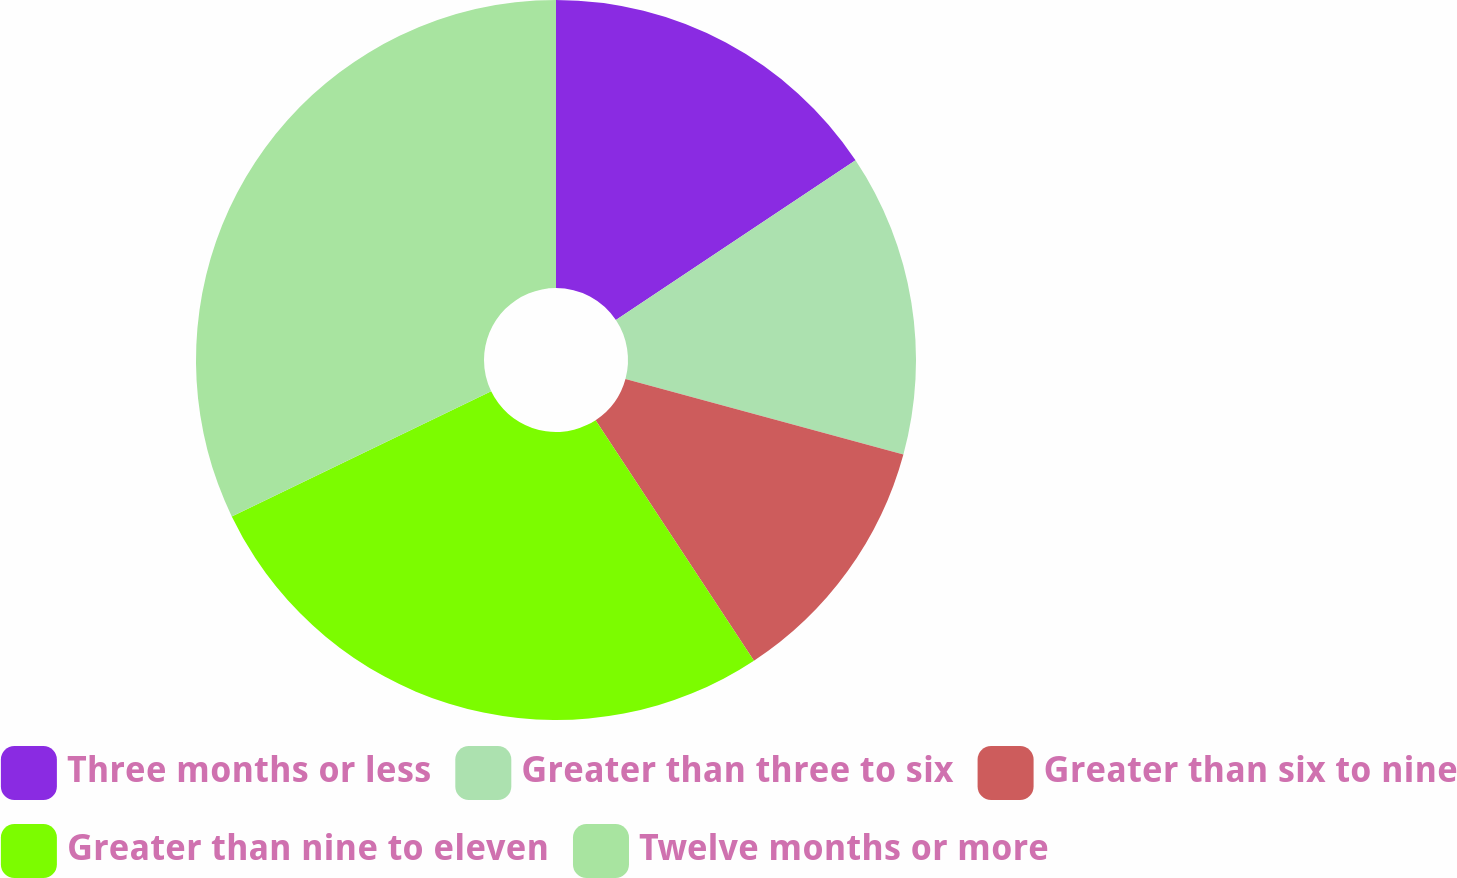<chart> <loc_0><loc_0><loc_500><loc_500><pie_chart><fcel>Three months or less<fcel>Greater than three to six<fcel>Greater than six to nine<fcel>Greater than nine to eleven<fcel>Twelve months or more<nl><fcel>15.64%<fcel>13.58%<fcel>11.51%<fcel>27.11%<fcel>32.15%<nl></chart> 